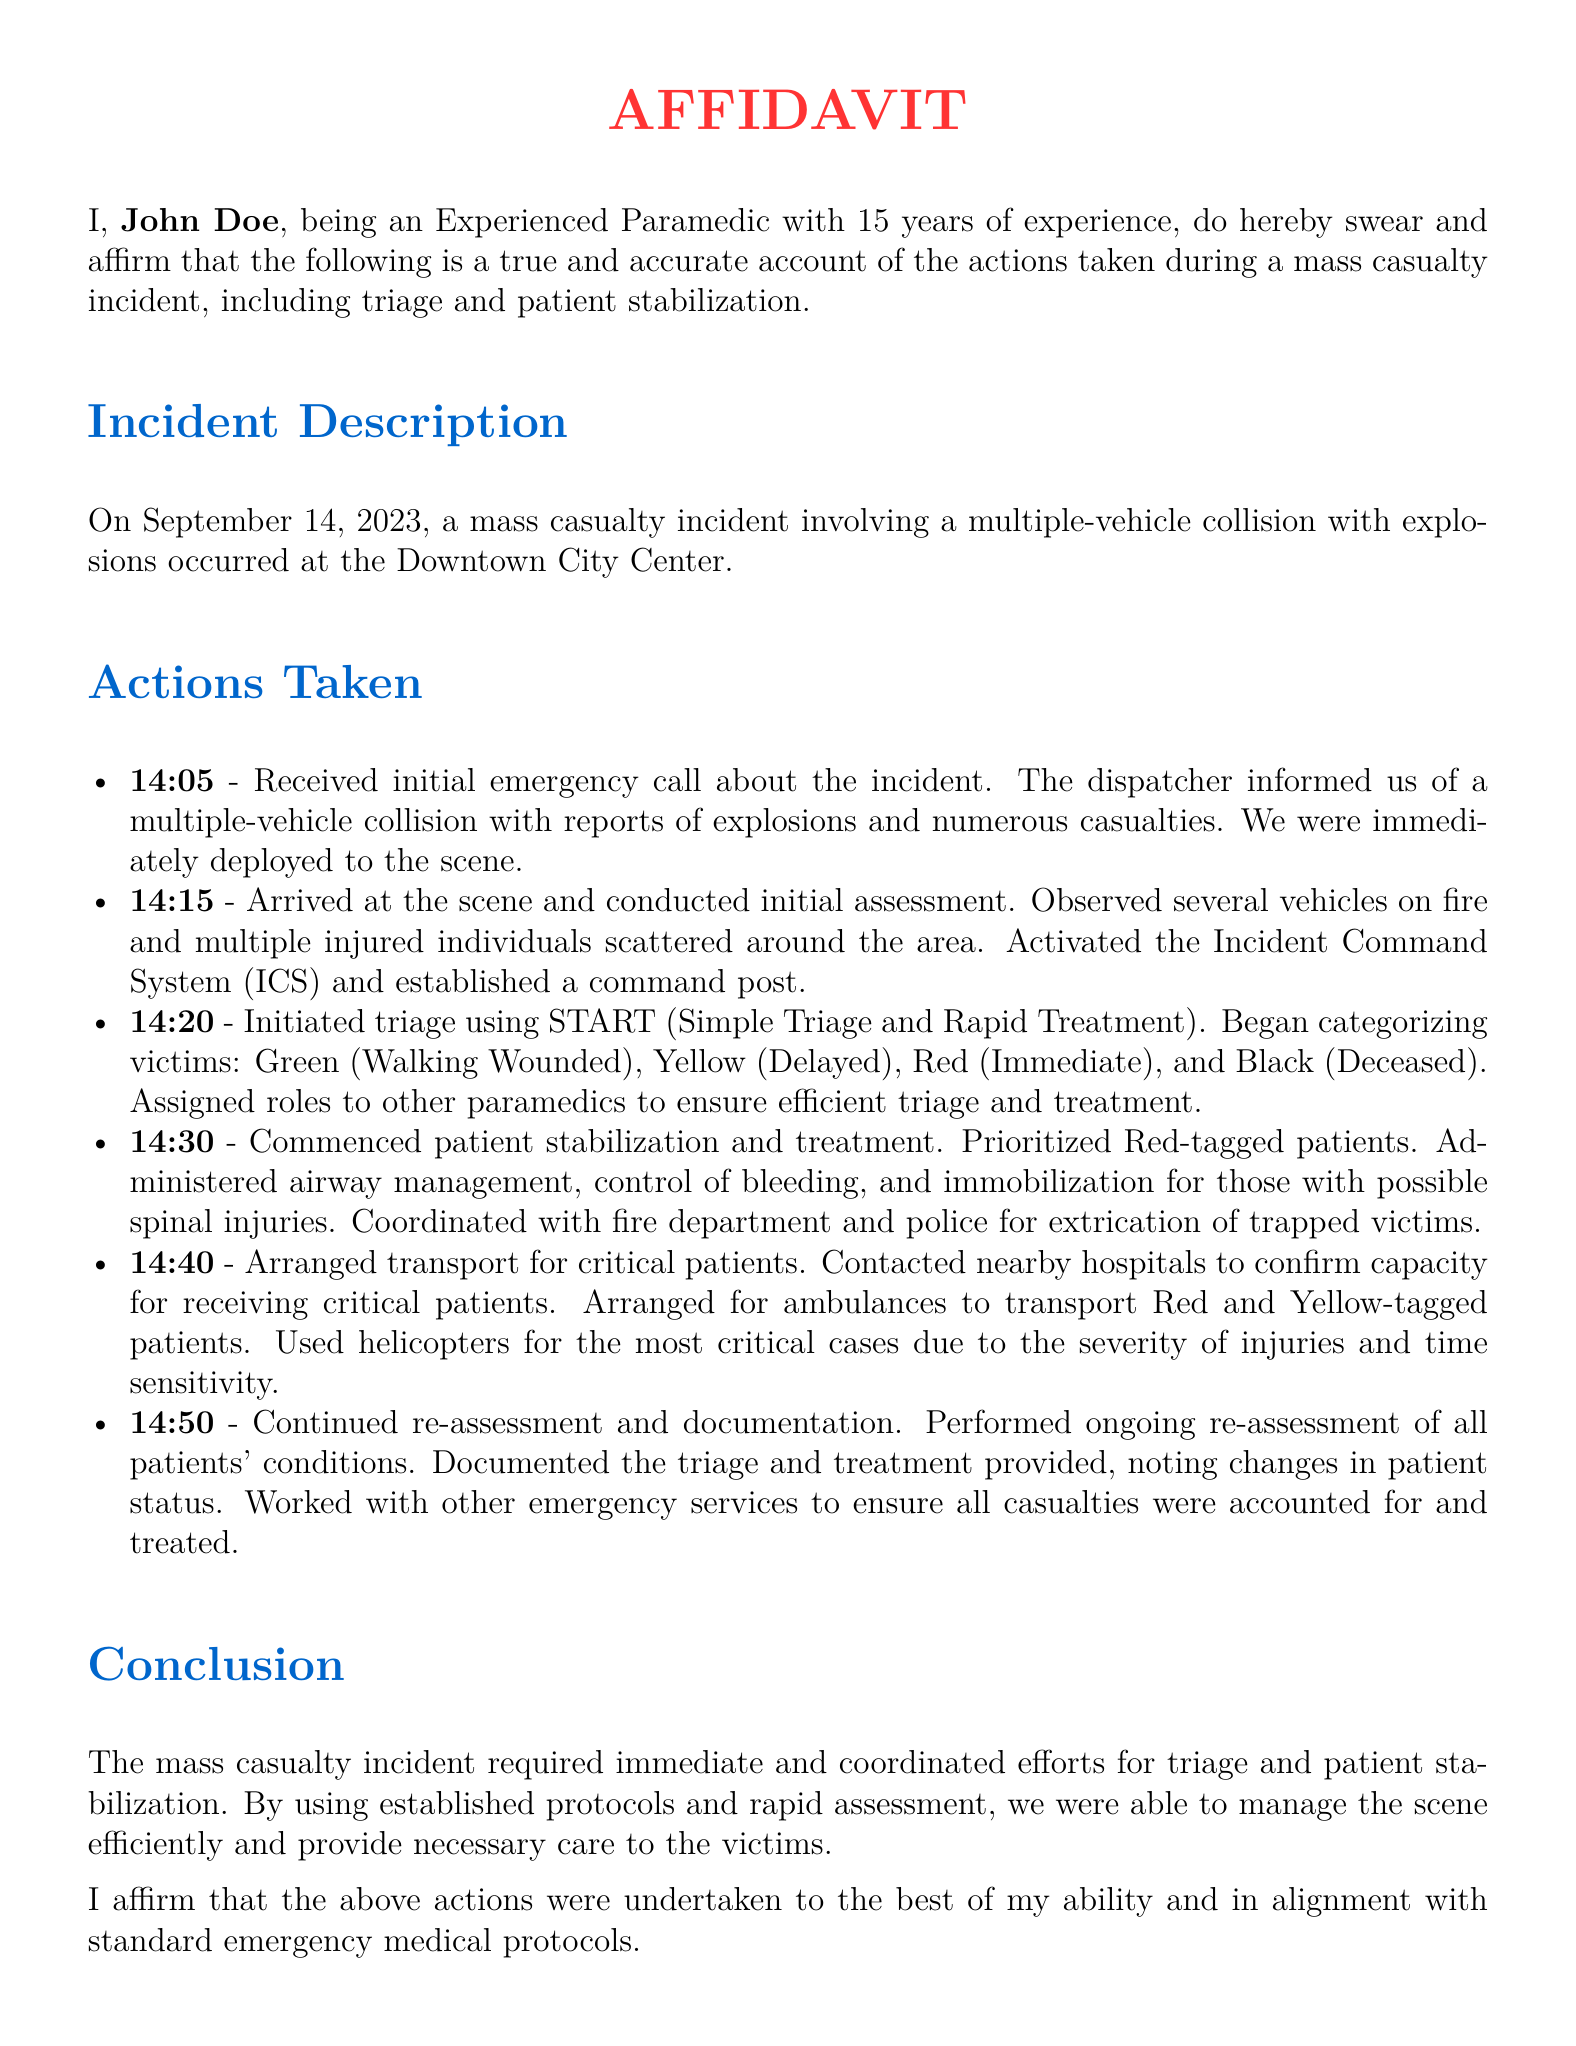What is the date of the mass casualty incident? The date of the incident is mentioned in the document, specifically when describing the incident.
Answer: September 14, 2023 Who is the author of the affidavit? The author is introduced at the beginning of the document, stating their name.
Answer: John Doe What time did the initial assessment occur? The time of the initial assessment is specified in the actions taken during the incident.
Answer: 14:15 What triage system was used? The document provides details about the triage system employed during the incident.
Answer: START What roles were assigned to other paramedics? The document indicates that roles were assigned to ensure efficient triage and treatment.
Answer: Triage and treatment At what time was patient stabilization commenced? The document lists the time when patient stabilization began during the actions taken.
Answer: 14:30 How were the most critical cases transported? The document specifies the means of transport for the most critical patients referenced in the actions taken.
Answer: Helicopters What was activated upon arrival at the scene? The document notes a specific protocol that was activated upon arrival at the incident scene.
Answer: Incident Command System What was documented during reassessment? The document indicates what was documented during the ongoing reassessment of patients.
Answer: Triage and treatment provided 